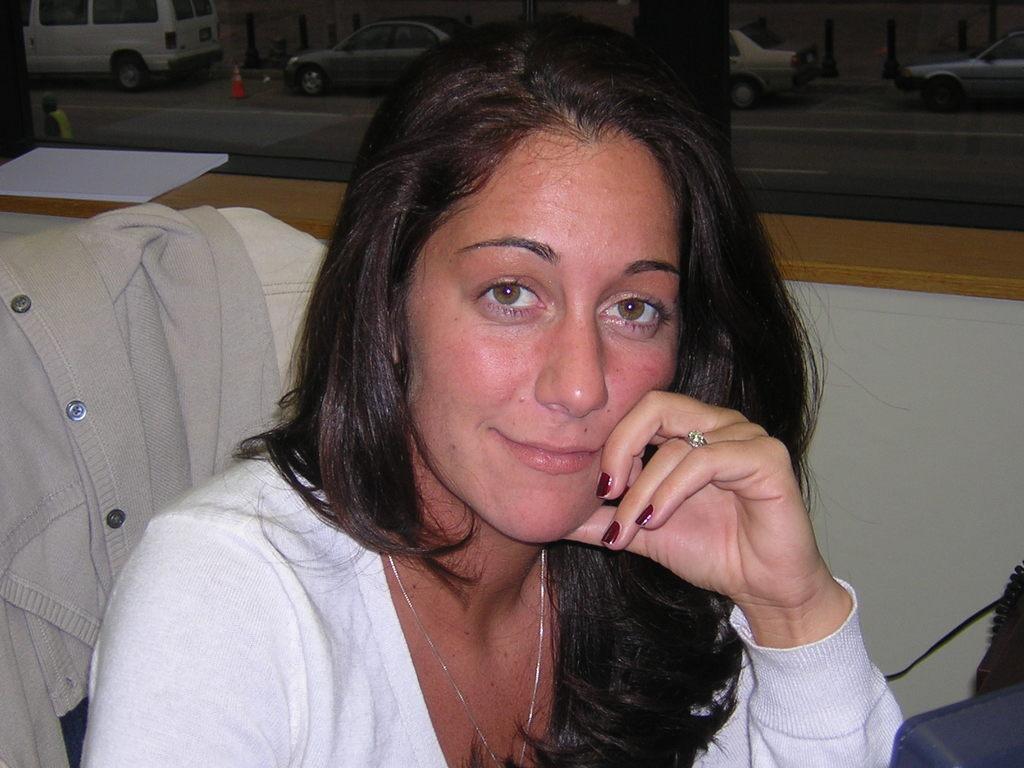How would you summarize this image in a sentence or two? In the center of this picture we can see a woman wearing white color dress, smiling and sitting on the chair and we can see an object seems to be the sweater placed on the chair and in the background we can see a safety cone and group of cars and we can see the road and some other objects. 